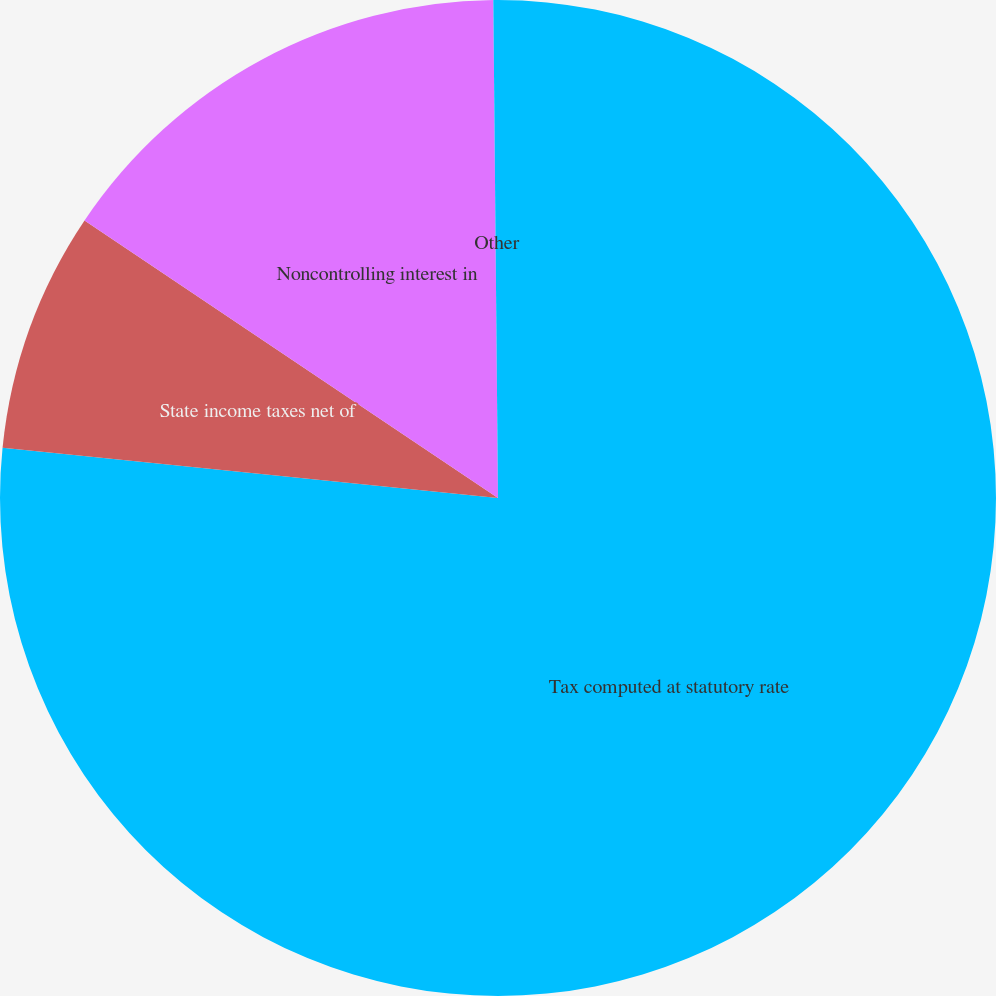Convert chart to OTSL. <chart><loc_0><loc_0><loc_500><loc_500><pie_chart><fcel>Tax computed at statutory rate<fcel>State income taxes net of<fcel>Noncontrolling interest in<fcel>Other<nl><fcel>76.61%<fcel>7.8%<fcel>15.44%<fcel>0.15%<nl></chart> 